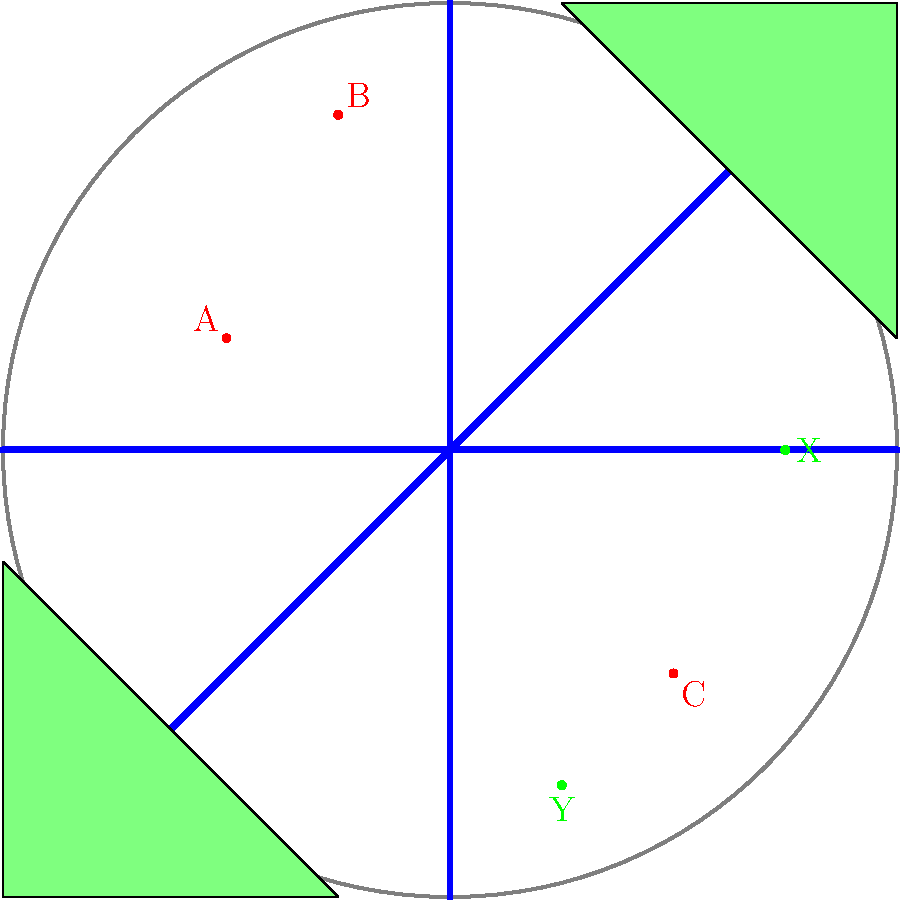In this top-down map of a MOBA game, three players from the red team (A, B, C) and two players from the green team (X, Y) are shown. Based on their positioning, which strategic move should the red team prioritize to gain a numerical advantage? To analyze this situation and determine the best strategic move for the red team, let's break it down step-by-step:

1. Player positions:
   - Red team: A (-2,1), B (-1,3), C (2,-2)
   - Green team: X (3,0), Y (1,-3)

2. Map analysis:
   - The map shows three lanes (top, middle, bottom) and jungle areas.
   - Players are spread across different areas of the map.

3. Numerical advantage:
   - Red team has 3 players, Green team has 2 players.
   - Red already has a numerical advantage, but they're not grouped together.

4. Potential targets:
   - Player X is isolated in the right side of the map.
   - Player Y is alone in the bottom lane.

5. Distance and grouping:
   - Players A and B are relatively close to each other.
   - Player C is closer to the enemy players.

6. Strategic considerations:
   - Grouping A and B to attack X could leave Y free to push the bottom lane.
   - Moving C to attack Y might be risky as X could counter-attack.

7. Optimal move:
   - The best strategy would be for A and B to quickly move and engage X.
   - This creates a 2v1 situation, likely resulting in a kill or forcing X to retreat.
   - C can maintain pressure in the bottom lane, preventing Y from pushing.

8. Outcome:
   - If executed correctly, this move could result in eliminating X without losing map control.
   - It maximizes the use of the red team's numerical advantage.

Therefore, the red team should prioritize grouping A and B to engage and eliminate X, creating a stronger numerical advantage and map control.
Answer: Group A and B to eliminate X 